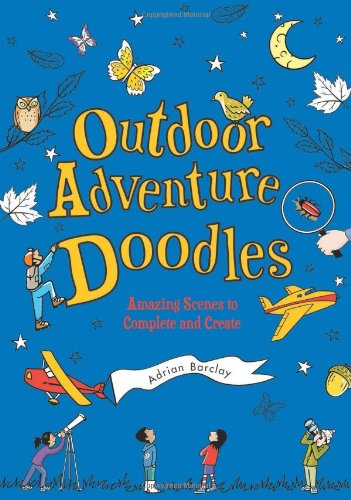Can you describe one of the activities mentioned in this book? One of the engaging activities in this book involves completing a scene where kids use their imagination to doodle different types of insects and creatures in a forest setting, thus enhancing their observation and artistic skills. 